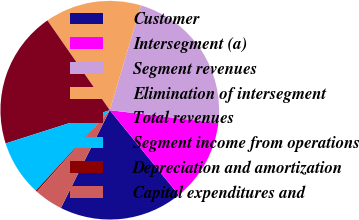<chart> <loc_0><loc_0><loc_500><loc_500><pie_chart><fcel>Customer<fcel>Intersegment (a)<fcel>Segment revenues<fcel>Elimination of intersegment<fcel>Total revenues<fcel>Segment income from operations<fcel>Depreciation and amortization<fcel>Capital expenditures and<nl><fcel>18.25%<fcel>12.26%<fcel>22.27%<fcel>14.27%<fcel>20.26%<fcel>8.25%<fcel>0.22%<fcel>4.23%<nl></chart> 